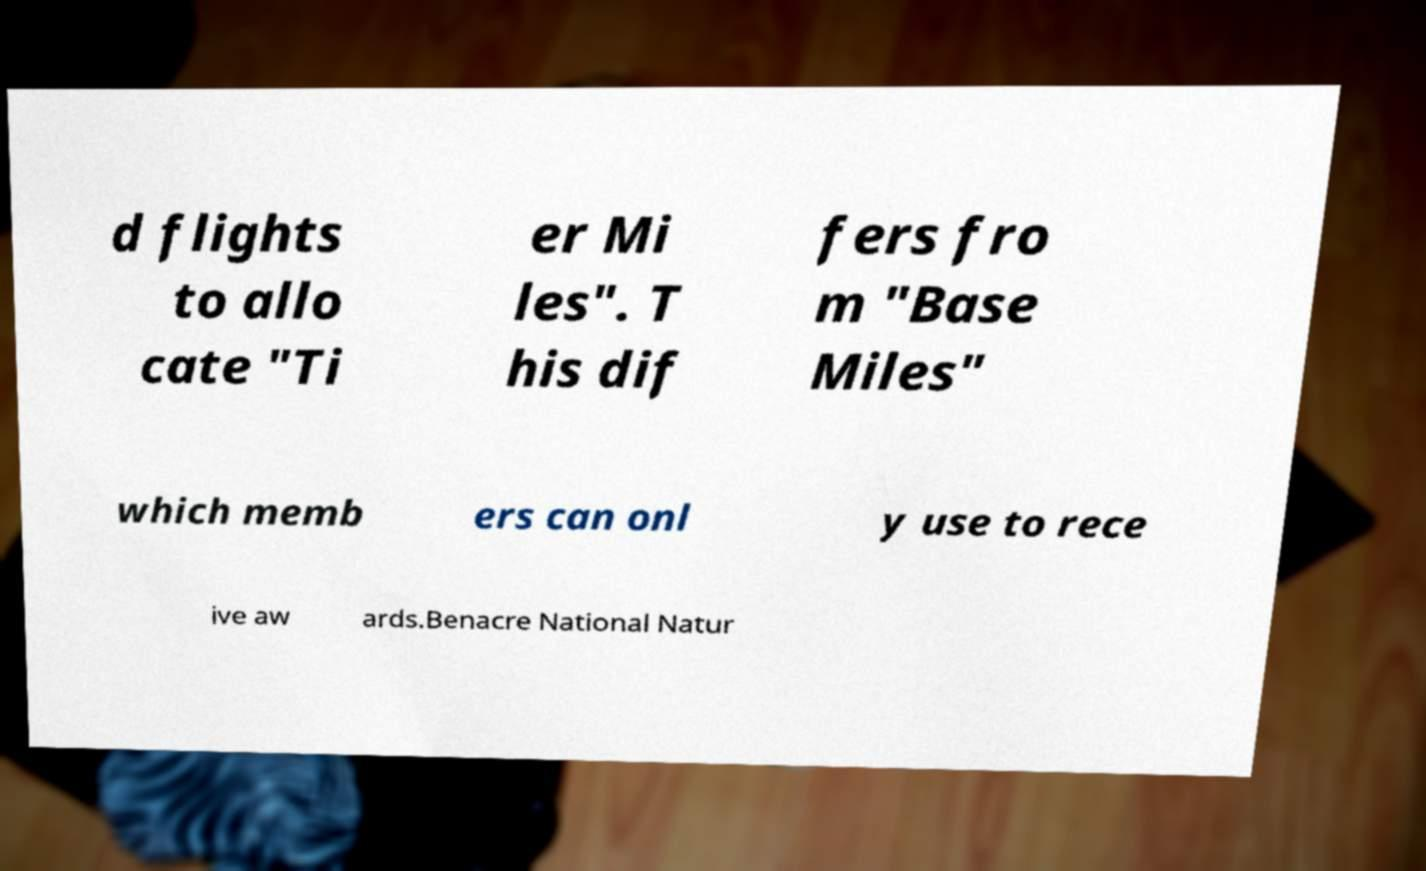What messages or text are displayed in this image? I need them in a readable, typed format. d flights to allo cate "Ti er Mi les". T his dif fers fro m "Base Miles" which memb ers can onl y use to rece ive aw ards.Benacre National Natur 